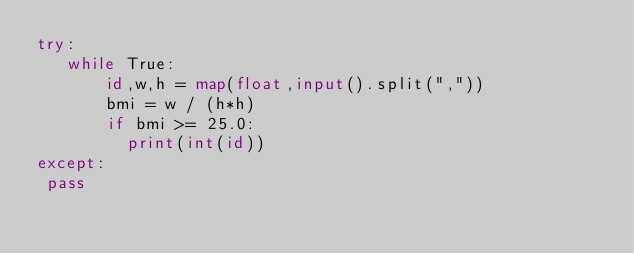<code> <loc_0><loc_0><loc_500><loc_500><_Python_>try:
   while True:
       id,w,h = map(float,input().split(","))
       bmi = w / (h*h)
       if bmi >= 25.0:
         print(int(id))
except:
 pass
</code> 